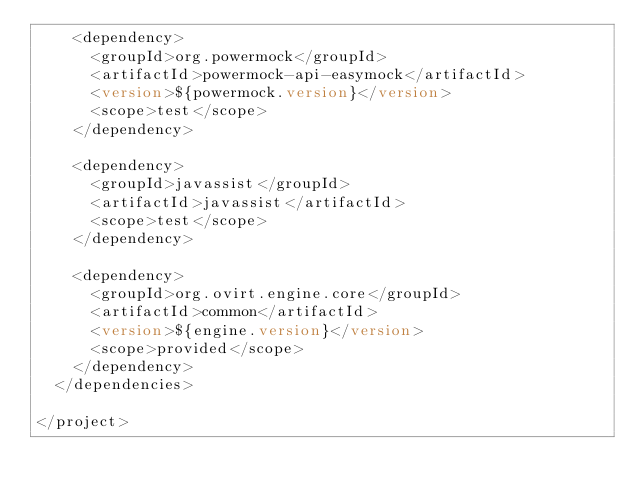Convert code to text. <code><loc_0><loc_0><loc_500><loc_500><_XML_>    <dependency>
      <groupId>org.powermock</groupId>
      <artifactId>powermock-api-easymock</artifactId>
      <version>${powermock.version}</version>
      <scope>test</scope>
    </dependency>

    <dependency>
      <groupId>javassist</groupId>
      <artifactId>javassist</artifactId>
      <scope>test</scope>
    </dependency>

    <dependency>
      <groupId>org.ovirt.engine.core</groupId>
      <artifactId>common</artifactId>
      <version>${engine.version}</version>
      <scope>provided</scope>
    </dependency>
  </dependencies>

</project>
</code> 